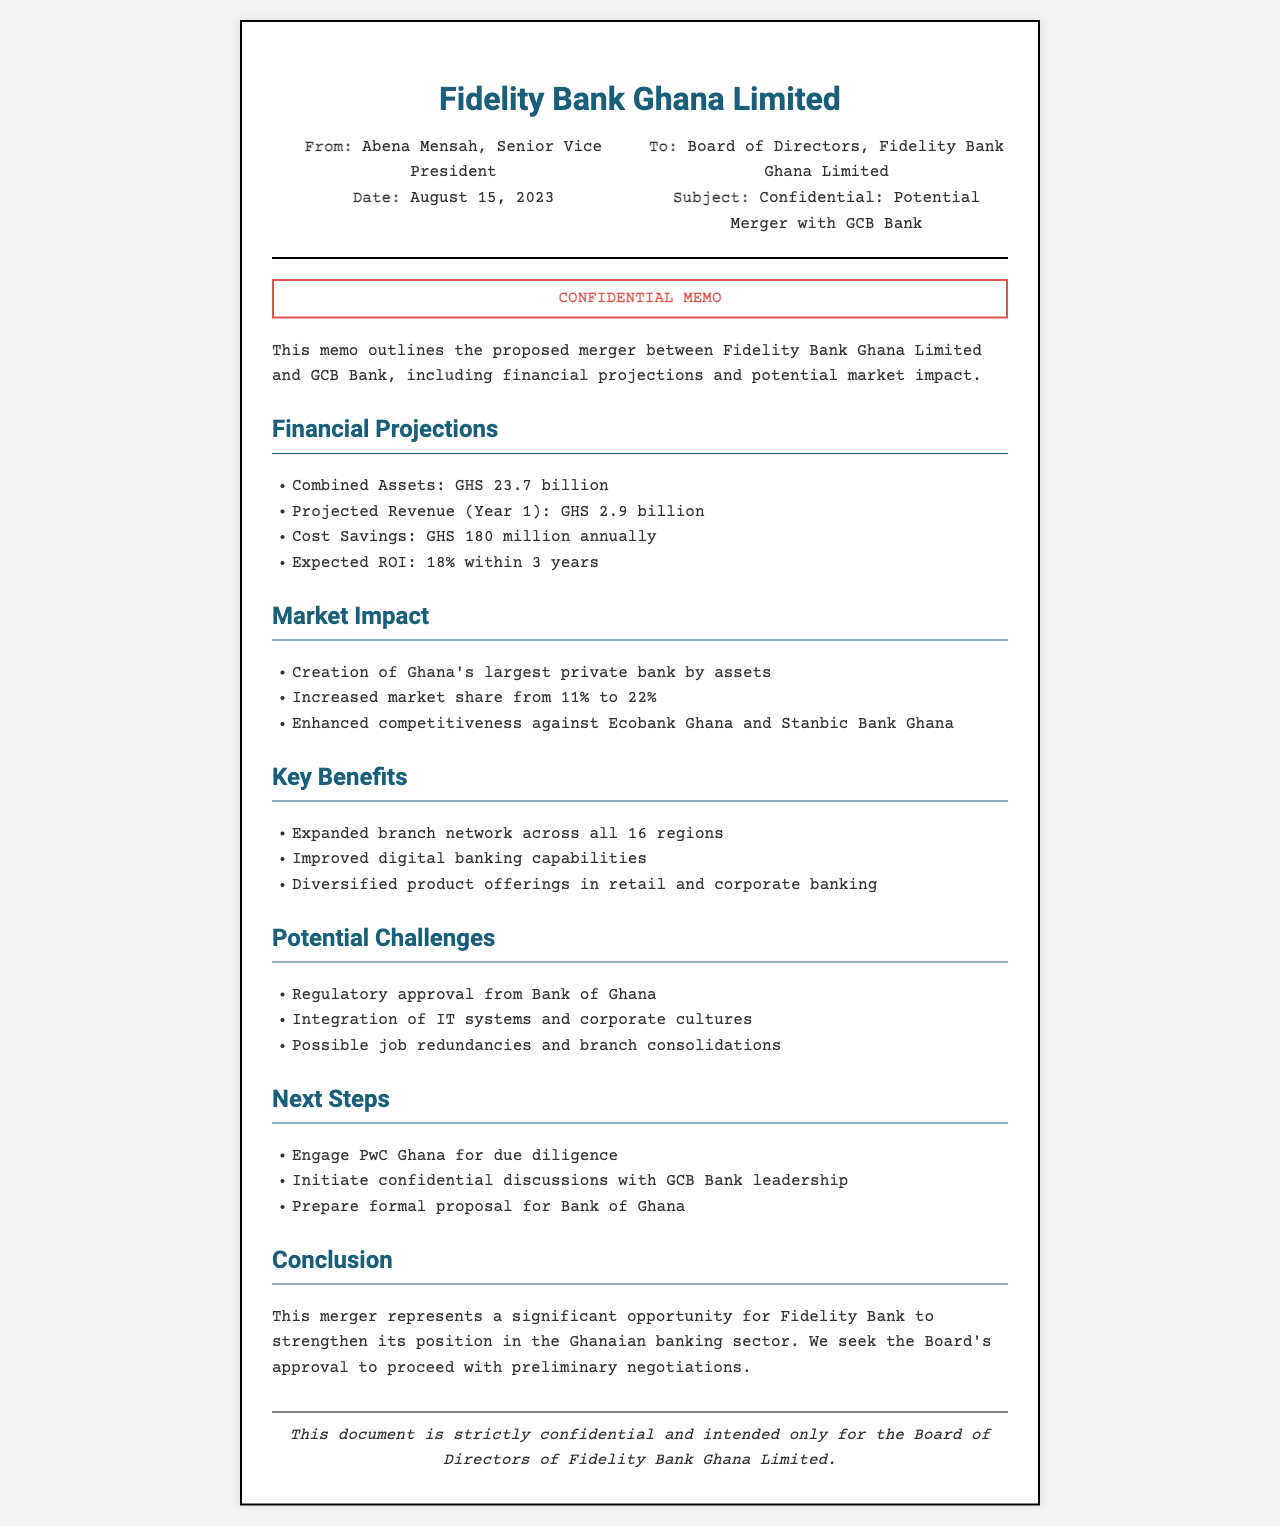what is the subject of the memo? The subject of the memo specifies the nature of the communication, which is a potential merger with GCB Bank.
Answer: Confidential: Potential Merger with GCB Bank who is the sender of the memo? The sender is identified in the document as Abena Mensah, the Senior Vice President.
Answer: Abena Mensah what is the projected revenue for Year 1? The projected revenue for Year 1 is explicitly mentioned in the financial projections section.
Answer: GHS 2.9 billion what is the expected ROI within 3 years? The expected ROI is noted within the financial projections section, highlighting the time frame and return on investment.
Answer: 18% what is the combined assets amount? The total combined assets after the proposed merger are specified in the financial projections.
Answer: GHS 23.7 billion what is one key benefit of the merger? The document lists various benefits; one has been selected here for illustration.
Answer: Expanded branch network across all 16 regions what is a potential challenge mentioned? The potential challenges associated with the merger are outlined in the document, with a specific challenge highlighted.
Answer: Regulatory approval from Bank of Ghana what is mentioned as a next step? The memo outlines next steps needed to advance the merger discussions, highlighting the main next action.
Answer: Engage PwC Ghana for due diligence 